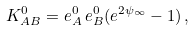Convert formula to latex. <formula><loc_0><loc_0><loc_500><loc_500>K _ { A B } ^ { 0 } = e _ { A } ^ { 0 } \, e _ { B } ^ { 0 } ( e ^ { 2 \psi _ { \infty } } - 1 ) \, ,</formula> 